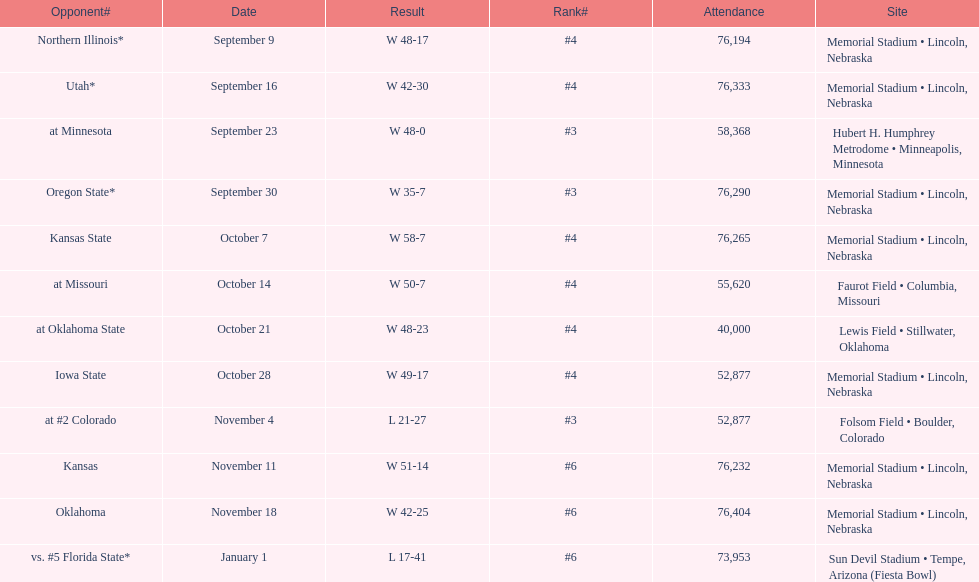On average how many times was w listed as the result? 10. 